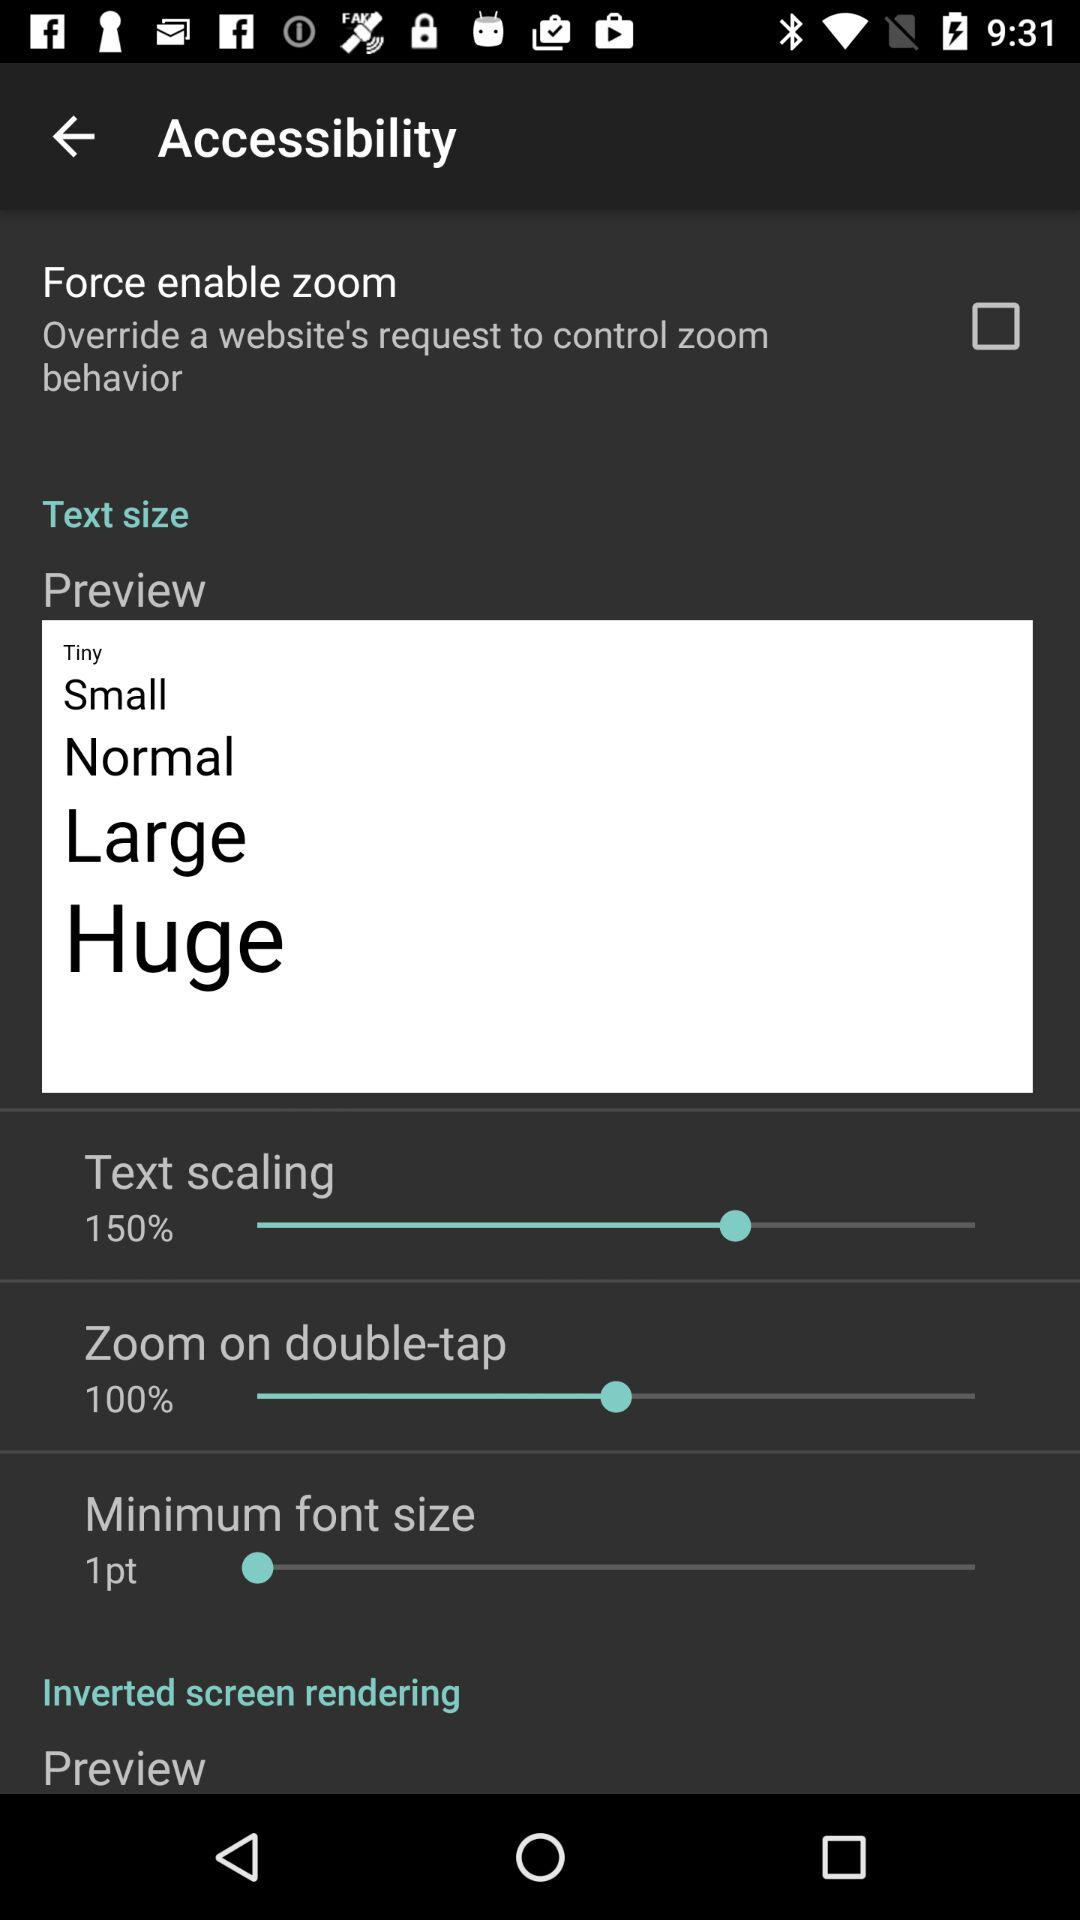Which option is set to 100%? The option that is set to 100% is "Zoom on double-tap". 